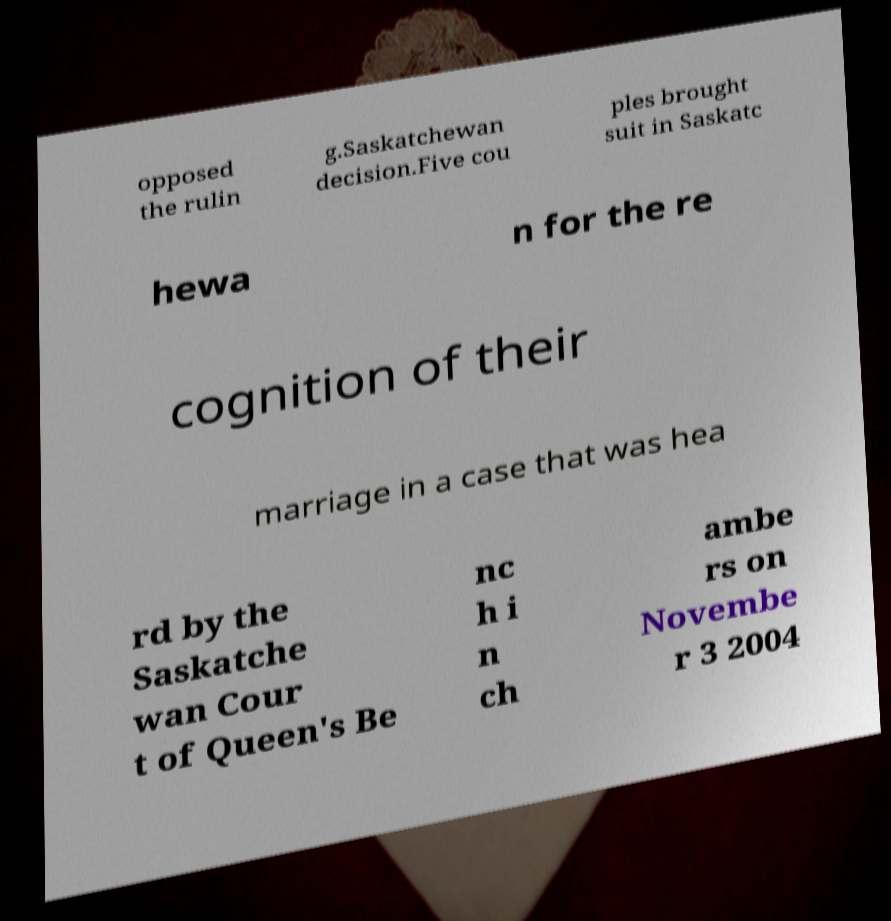I need the written content from this picture converted into text. Can you do that? opposed the rulin g.Saskatchewan decision.Five cou ples brought suit in Saskatc hewa n for the re cognition of their marriage in a case that was hea rd by the Saskatche wan Cour t of Queen's Be nc h i n ch ambe rs on Novembe r 3 2004 